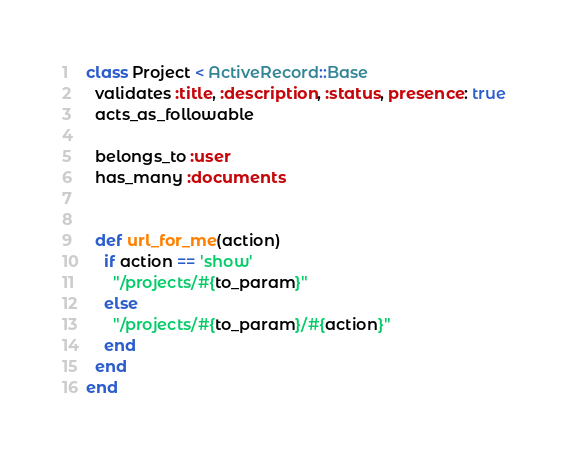Convert code to text. <code><loc_0><loc_0><loc_500><loc_500><_Ruby_>class Project < ActiveRecord::Base
  validates :title, :description, :status, presence: true
  acts_as_followable

  belongs_to :user
  has_many :documents


  def url_for_me(action)
    if action == 'show'
      "/projects/#{to_param}"
    else
      "/projects/#{to_param}/#{action}"
    end
  end
end
</code> 